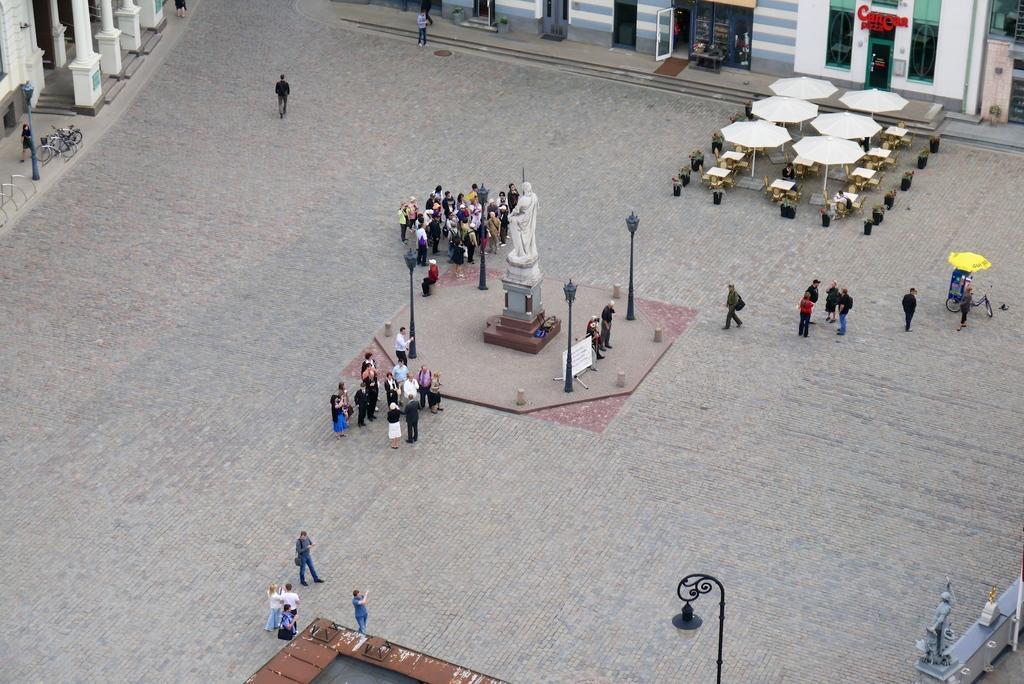Can you describe this image briefly? In the middle of the image we can see a statue. Surrounding the statue few people are standing, walking and we can see some poles. At the top of the image we can see some buildings. In the top right corner of the image we can see some umbrellas, tables, benches and plants. 